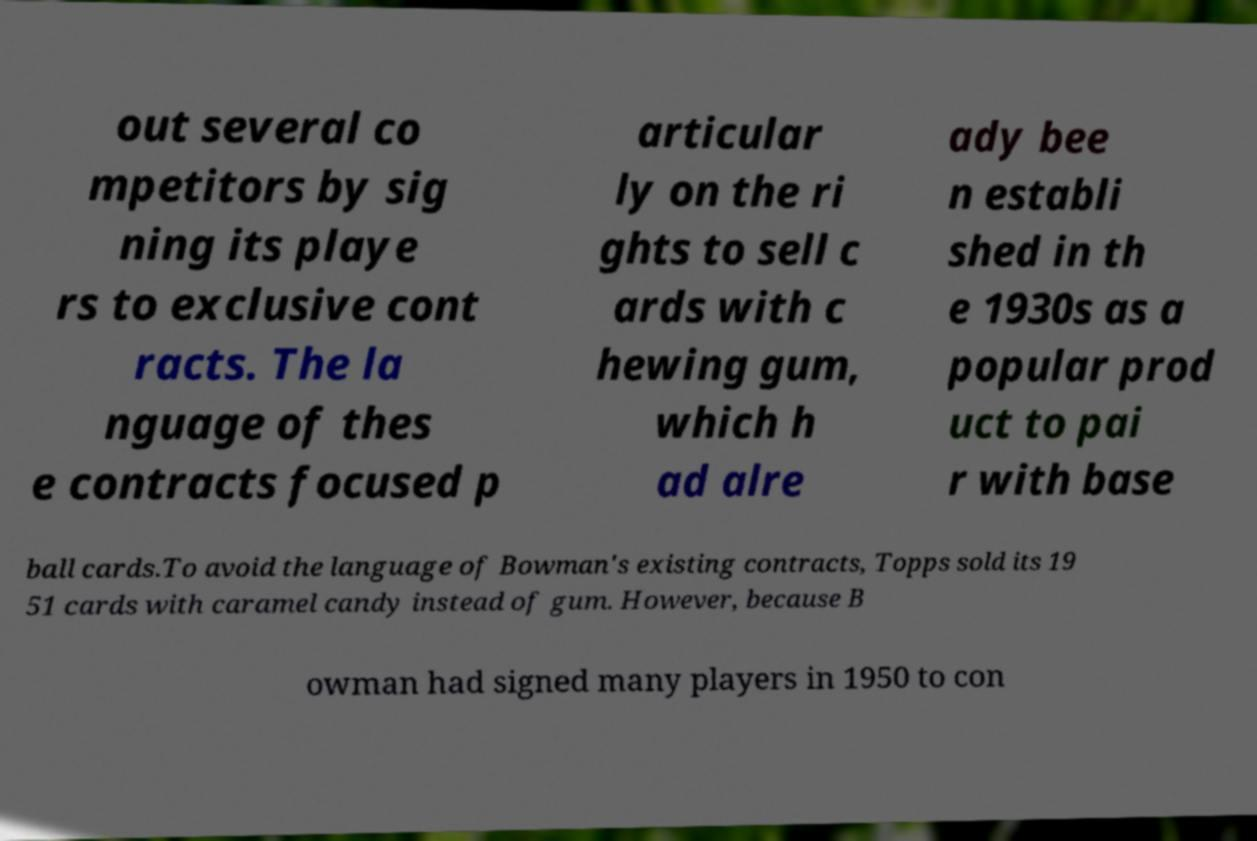For documentation purposes, I need the text within this image transcribed. Could you provide that? out several co mpetitors by sig ning its playe rs to exclusive cont racts. The la nguage of thes e contracts focused p articular ly on the ri ghts to sell c ards with c hewing gum, which h ad alre ady bee n establi shed in th e 1930s as a popular prod uct to pai r with base ball cards.To avoid the language of Bowman's existing contracts, Topps sold its 19 51 cards with caramel candy instead of gum. However, because B owman had signed many players in 1950 to con 